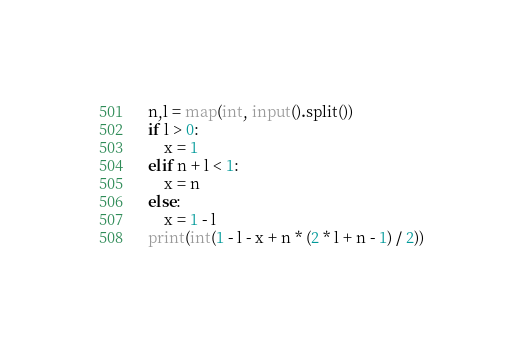Convert code to text. <code><loc_0><loc_0><loc_500><loc_500><_Python_>n,l = map(int, input().split())
if l > 0:
    x = 1
elif n + l < 1:
    x = n
else:
    x = 1 - l
print(int(1 - l - x + n * (2 * l + n - 1) / 2))</code> 